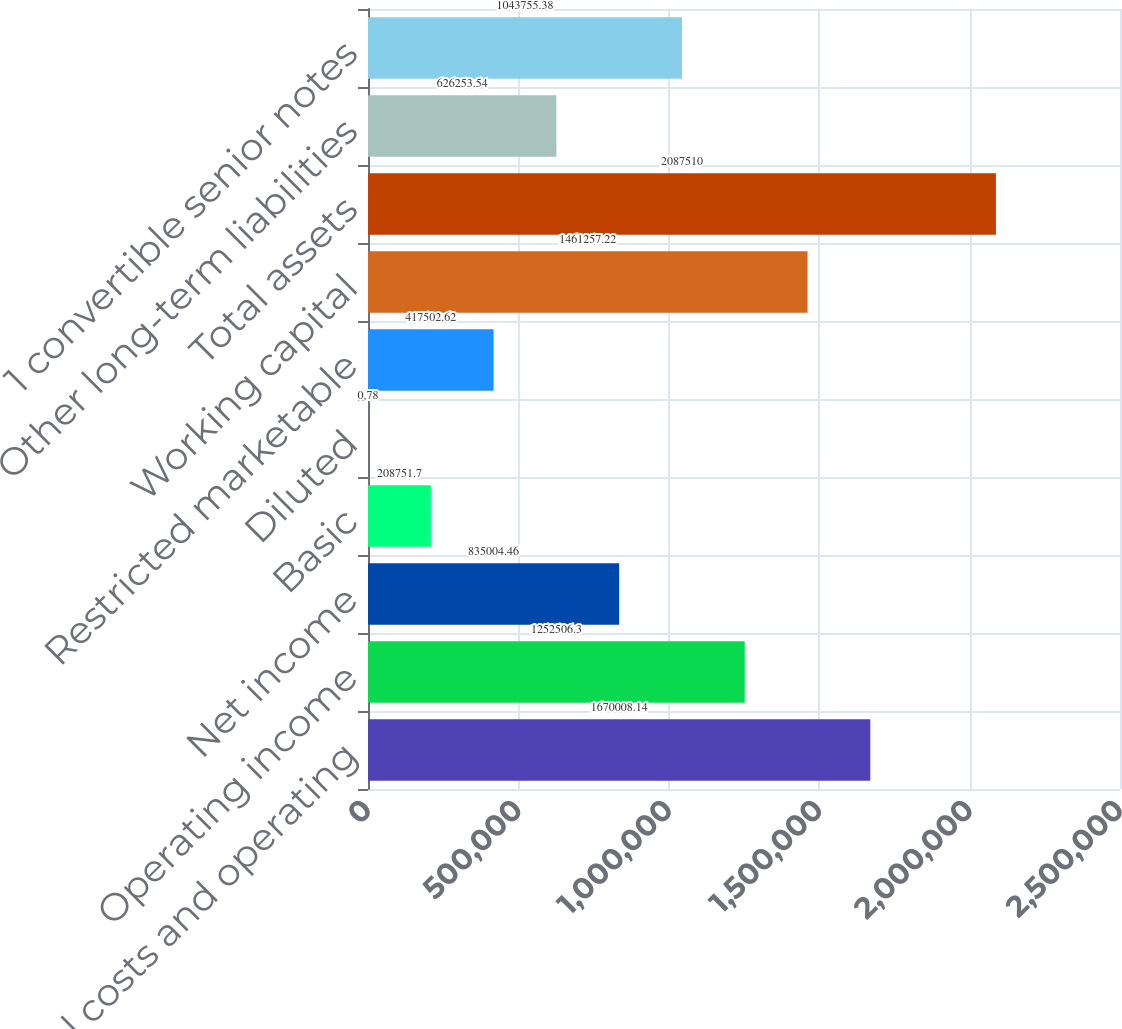<chart> <loc_0><loc_0><loc_500><loc_500><bar_chart><fcel>Total costs and operating<fcel>Operating income<fcel>Net income<fcel>Basic<fcel>Diluted<fcel>Restricted marketable<fcel>Working capital<fcel>Total assets<fcel>Other long-term liabilities<fcel>1 convertible senior notes<nl><fcel>1.67001e+06<fcel>1.25251e+06<fcel>835004<fcel>208752<fcel>0.78<fcel>417503<fcel>1.46126e+06<fcel>2.08751e+06<fcel>626254<fcel>1.04376e+06<nl></chart> 